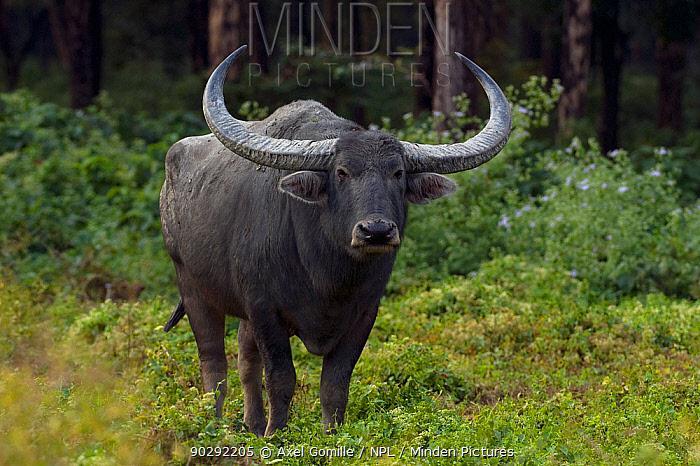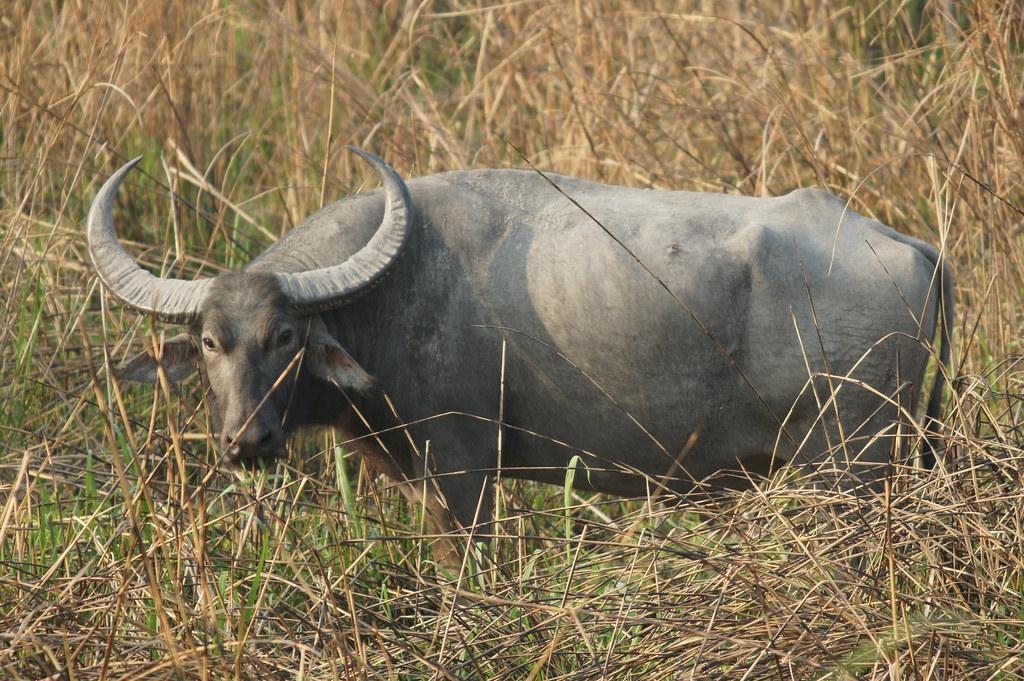The first image is the image on the left, the second image is the image on the right. For the images displayed, is the sentence "Two water buffalo are present in the left image." factually correct? Answer yes or no. No. 